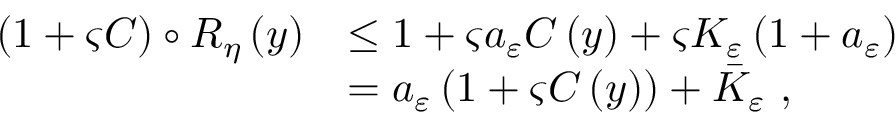Convert formula to latex. <formula><loc_0><loc_0><loc_500><loc_500>\begin{array} { r l } { \left ( 1 + \varsigma C \right ) \circ R _ { \eta } \left ( y \right ) } & { \leq 1 + \varsigma a _ { \varepsilon } C \left ( y \right ) + \varsigma K _ { \varepsilon } \left ( 1 + a _ { \varepsilon } \right ) } \\ & { = a _ { \varepsilon } \left ( 1 + \varsigma C \left ( y \right ) \right ) + \bar { K } _ { \varepsilon } \ , } \end{array}</formula> 